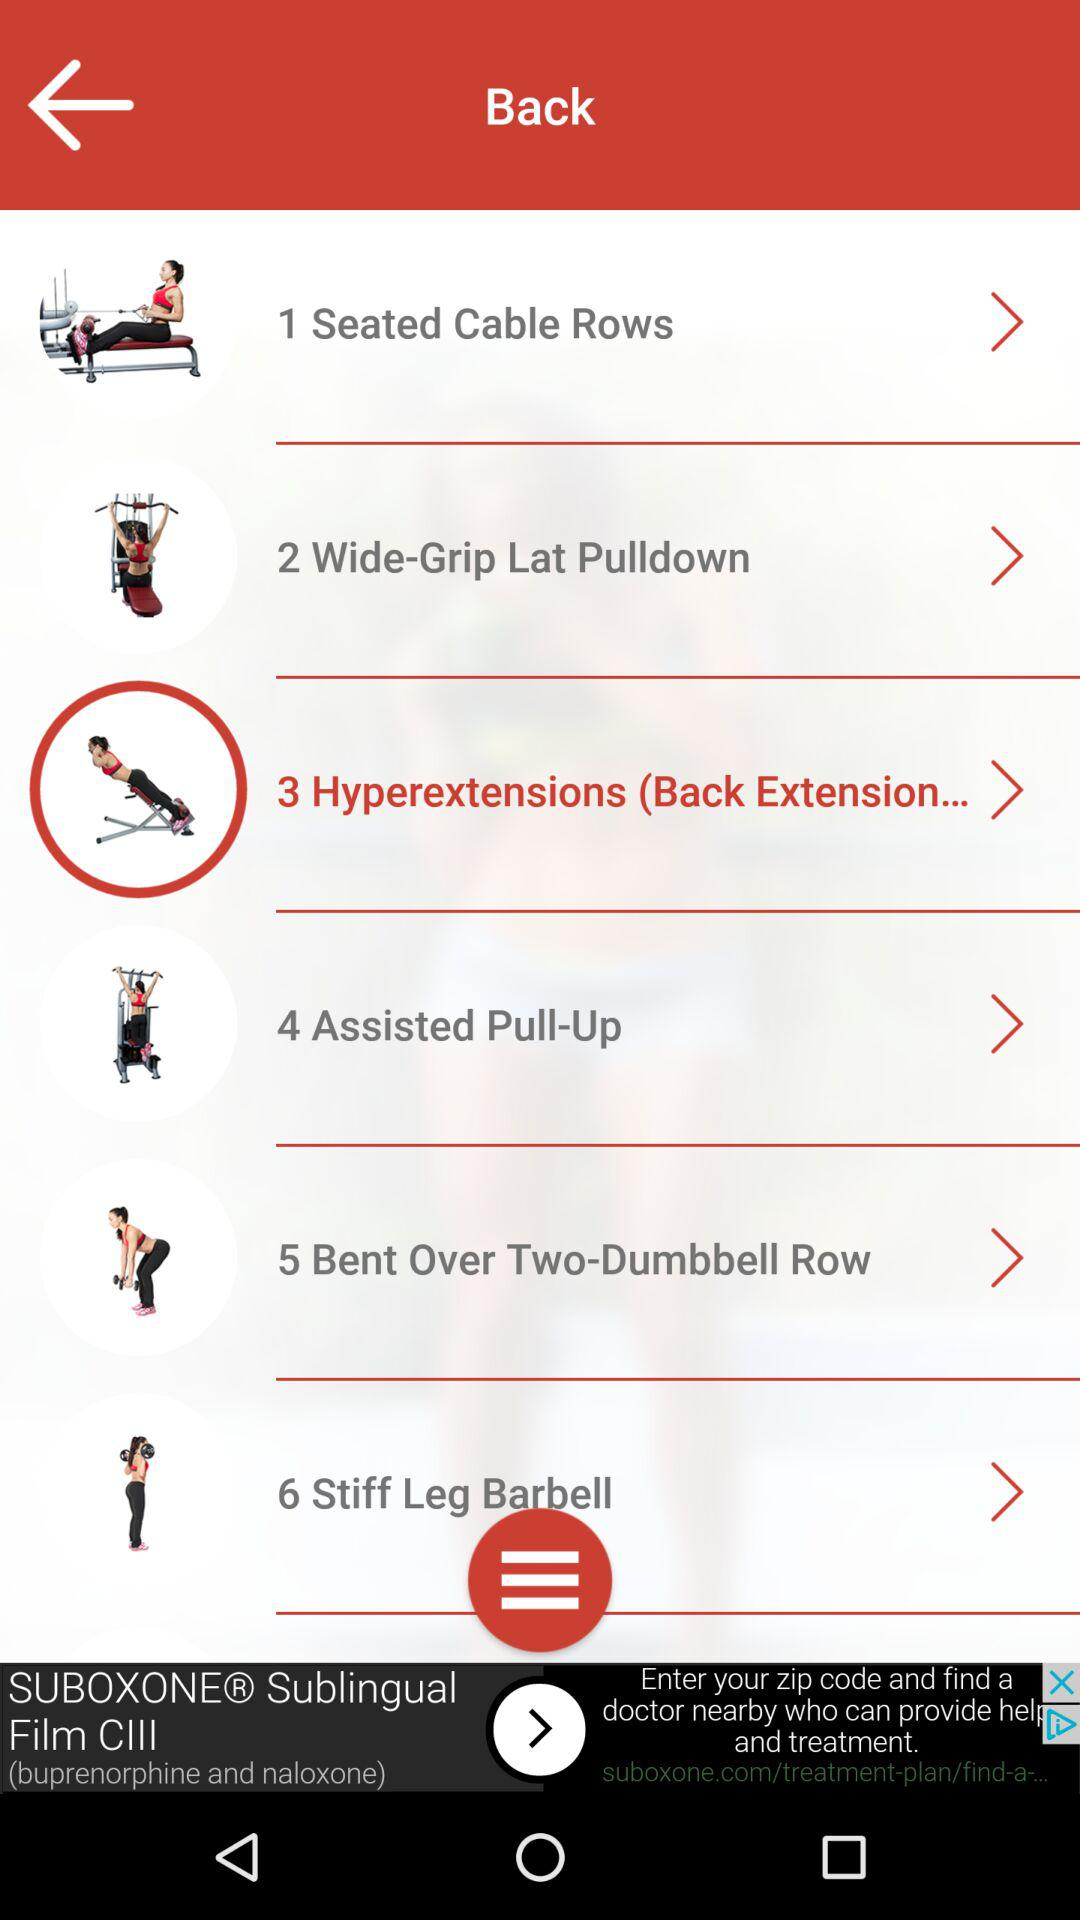What exercise is on number 4? The exercise is "Assisted Pull-Up". 